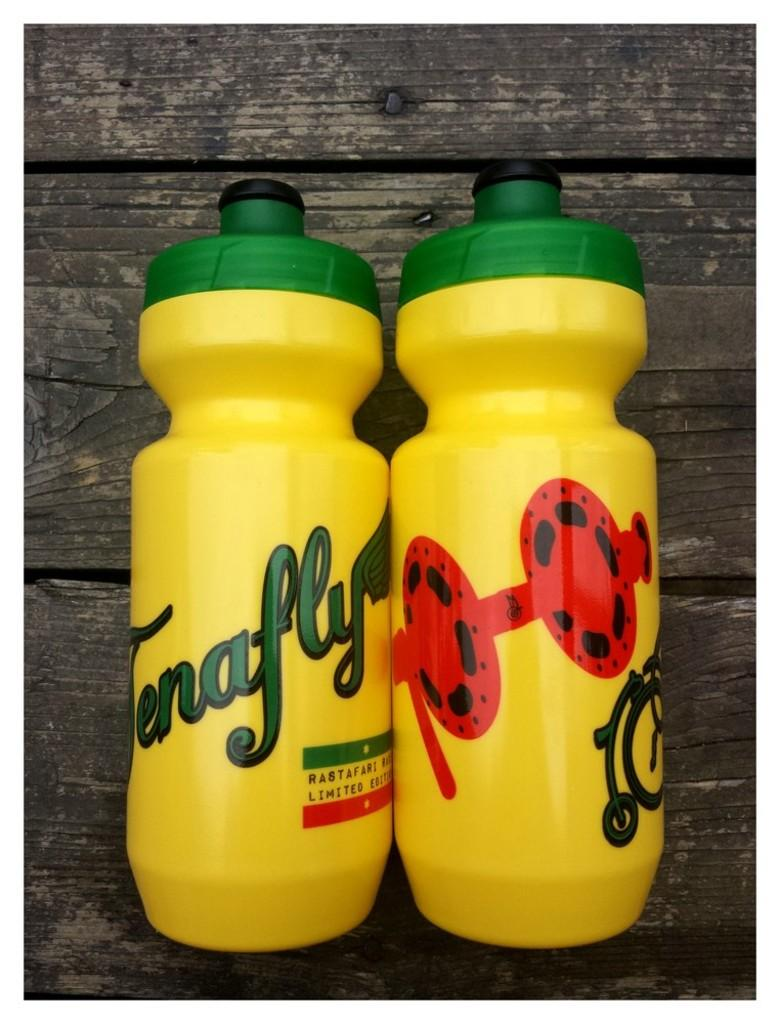<image>
Describe the image concisely. A decorated yellow and green bottle that reads Tenafly 